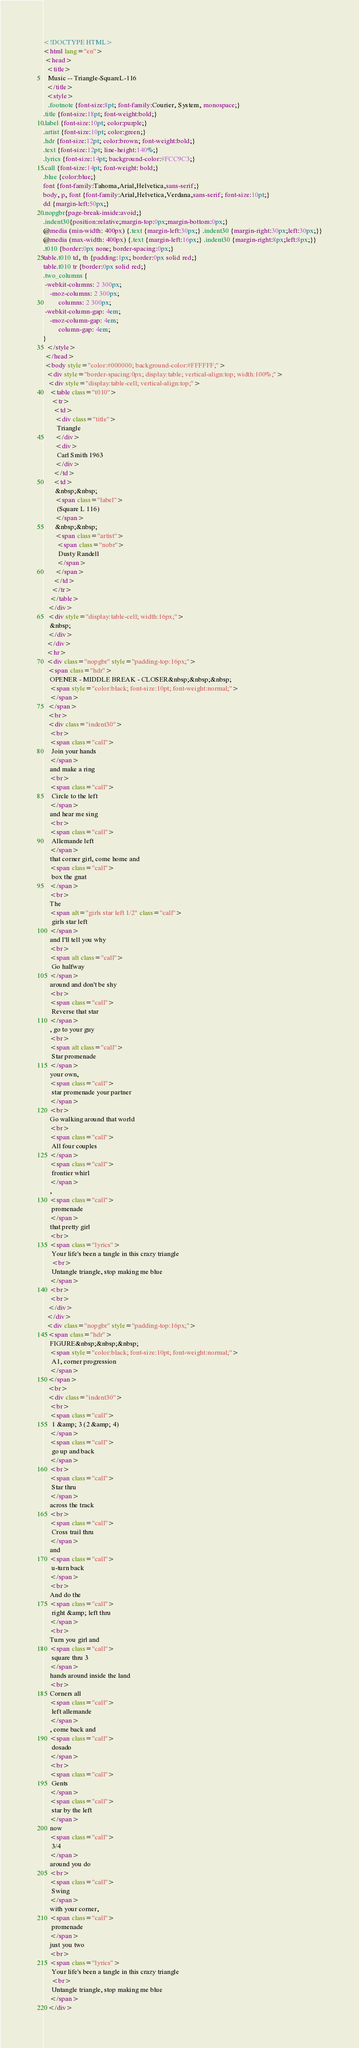<code> <loc_0><loc_0><loc_500><loc_500><_HTML_><!DOCTYPE HTML>
<html lang="en">
 <head>
  <title>
   Music -- Triangle-SquareL-116
  </title>
  <style>
   .footnote {font-size:8pt; font-family:Courier, System, monospace;}
.title {font-size:18pt; font-weight:bold;}
.label {font-size:10pt; color:purple;}
.artist {font-size:10pt; color:green;}
.hdr {font-size:12pt; color:brown; font-weight:bold;}
.text {font-size:12pt; line-height:140%;}
.lyrics {font-size:14pt; background-color:#FCC9C3;}
.call {font-size:14pt; font-weight: bold;}
.blue {color:blue;}
font {font-family:Tahoma,Arial,Helvetica,sans-serif;}
body, p, font {font-family:Arial,Helvetica,Verdana,sans-serif; font-size:10pt;}
dd {margin-left:50px;}
.nopgbr{page-break-inside:avoid;}
.indent30{position:relative;margin-top:0px;margin-bottom:0px;}
@media (min-width: 400px) {.text {margin-left:30px;} .indent30 {margin-right:30px;left:30px;}}
@media (max-width: 400px) {.text {margin-left:16px;} .indent30 {margin-right:8px;left:8px;}}
.t010 {border:0px none; border-spacing:0px;}
table.t010 td, th {padding:1px; border:0px solid red;}
table.t010 tr {border:0px solid red;}
.two_columns {
 -webkit-columns: 2 300px;
    -moz-columns: 2 300px;
         columns: 2 300px;
 -webkit-column-gap: 4em;
    -moz-column-gap: 4em;
         column-gap: 4em;
}
  </style>
 </head>
 <body style="color:#000000; background-color:#FFFFFF;">
  <div style="border-spacing:0px; display:table; vertical-align:top; width:100%;">
   <div style="display:table-cell; vertical-align:top;">
    <table class="t010">
     <tr>
      <td>
       <div class="title">
        Triangle
       </div>
       <div>
        Carl Smith 1963
       </div>
      </td>
      <td>
       &nbsp;&nbsp;
       <span class="label">
        (Square L 116)
       </span>
       &nbsp;&nbsp;
       <span class="artist">
        <span class="nobr">
         Dusty Randell
        </span>
       </span>
      </td>
     </tr>
    </table>
   </div>
   <div style="display:table-cell; width:16px;">
    &nbsp;
   </div>
  </div>
  <hr>
  <div class="nopgbr" style="padding-top:16px;">
   <span class="hdr">
    OPENER - MIDDLE BREAK - CLOSER&nbsp;&nbsp;&nbsp;
    <span style="color:black; font-size:10pt; font-weight:normal;">
    </span>
   </span>
   <br>
   <div class="indent30">
    <br>
    <span class="call">
     Join your hands
    </span>
    and make a ring
    <br>
    <span class="call">
     Circle to the left
    </span>
    and hear me sing
    <br>
    <span class="call">
     Allemande left
    </span>
    that corner girl, come home and
    <span class="call">
     box the gnat
    </span>
    <br>
    The
    <span alt="girls star left 1/2" class="call">
     girls star left
    </span>
    and I'll tell you why
    <br>
    <span alt class="call">
     Go halfway
    </span>
    around and don't be shy
    <br>
    <span class="call">
     Reverse that star
    </span>
    , go to your guy
    <br>
    <span alt class="call">
     Star promenade
    </span>
    your own,
    <span class="call">
     star promenade your partner
    </span>
    <br>
    Go walking around that world
    <br>
    <span class="call">
     All four couples
    </span>
    <span class="call">
     frontier whirl
    </span>
    ,
    <span class="call">
     promenade
    </span>
    that pretty girl
    <br>
    <span class="lyrics">
     Your life's been a tangle in this crazy triangle
     <br>
     Untangle triangle, stop making me blue
    </span>
    <br>
    <br>
   </div>
  </div>
  <div class="nopgbr" style="padding-top:16px;">
   <span class="hdr">
    FIGURE&nbsp;&nbsp;&nbsp;
    <span style="color:black; font-size:10pt; font-weight:normal;">
     A1, corner progression
    </span>
   </span>
   <br>
   <div class="indent30">
    <br>
    <span class="call">
     1 &amp; 3 (2 &amp; 4)
    </span>
    <span class="call">
     go up and back
    </span>
    <br>
    <span class="call">
     Star thru
    </span>
    across the track
    <br>
    <span class="call">
     Cross trail thru
    </span>
    and
    <span class="call">
     u-turn back
    </span>
    <br>
    And do the
    <span class="call">
     right &amp; left thru
    </span>
    <br>
    Turn you girl and
    <span class="call">
     square thru 3
    </span>
    hands around inside the land
    <br>
    Corners all
    <span class="call">
     left allemande
    </span>
    , come back and
    <span class="call">
     dosado
    </span>
    <br>
    <span class="call">
     Gents
    </span>
    <span class="call">
     star by the left
    </span>
    now
    <span class="call">
     3/4
    </span>
    around you do
    <br>
    <span class="call">
     Swing
    </span>
    with your corner,
    <span class="call">
     promenade
    </span>
    just you two
    <br>
    <span class="lyrics">
     Your life's been a tangle in this crazy triangle
     <br>
     Untangle triangle, stop making me blue
    </span>
   </div></code> 